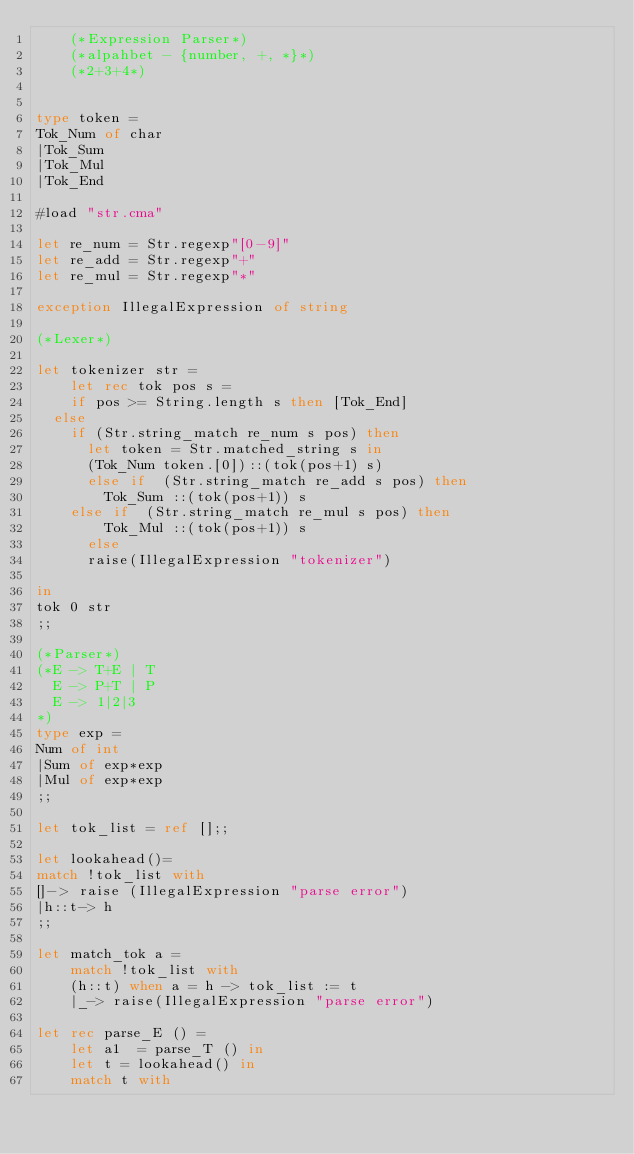Convert code to text. <code><loc_0><loc_0><loc_500><loc_500><_OCaml_>	(*Expression Parser*)
	(*alpahbet - {number, +, *}*)
	(*2+3+4*)


type token =
Tok_Num of char
|Tok_Sum
|Tok_Mul
|Tok_End

#load "str.cma"

let re_num = Str.regexp"[0-9]"
let re_add = Str.regexp"+"
let re_mul = Str.regexp"*"

exception IllegalExpression of string 

(*Lexer*)

let tokenizer str = 
	let rec tok pos s =
	if pos >= String.length s then [Tok_End]
  else
	if (Str.string_match re_num s pos) then
	  let token = Str.matched_string s in
	  (Tok_Num token.[0])::(tok(pos+1) s)
	  else if  (Str.string_match re_add s pos) then
	    Tok_Sum ::(tok(pos+1)) s
	else if  (Str.string_match re_mul s pos) then
	    Tok_Mul ::(tok(pos+1)) s
	  else
	  raise(IllegalExpression "tokenizer")

in 
tok 0 str
;;

(*Parser*)
(*E -> T+E | T
  E -> P+T | P
  E -> 1|2|3
*)
type exp = 
Num of int
|Sum of exp*exp
|Mul of exp*exp
;;

let tok_list = ref [];;

let lookahead()=
match !tok_list with
[]-> raise (IllegalExpression "parse error")
|h::t-> h
;;

let match_tok a =
	match !tok_list with
	(h::t) when a = h -> tok_list := t
    |_-> raise(IllegalExpression "parse error")

let rec parse_E () = 
	let a1  = parse_T () in
	let t = lookahead() in
	match t with</code> 